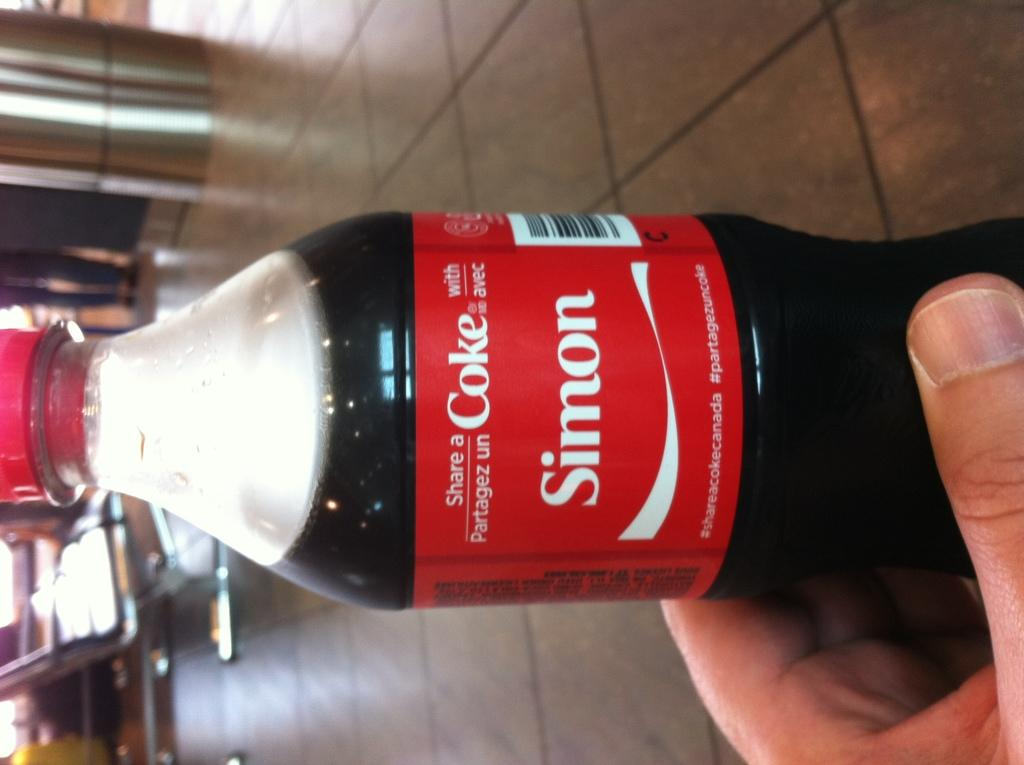Provide a one-sentence caption for the provided image. A bottle of coke has the phrase, share a coke with Simon. 